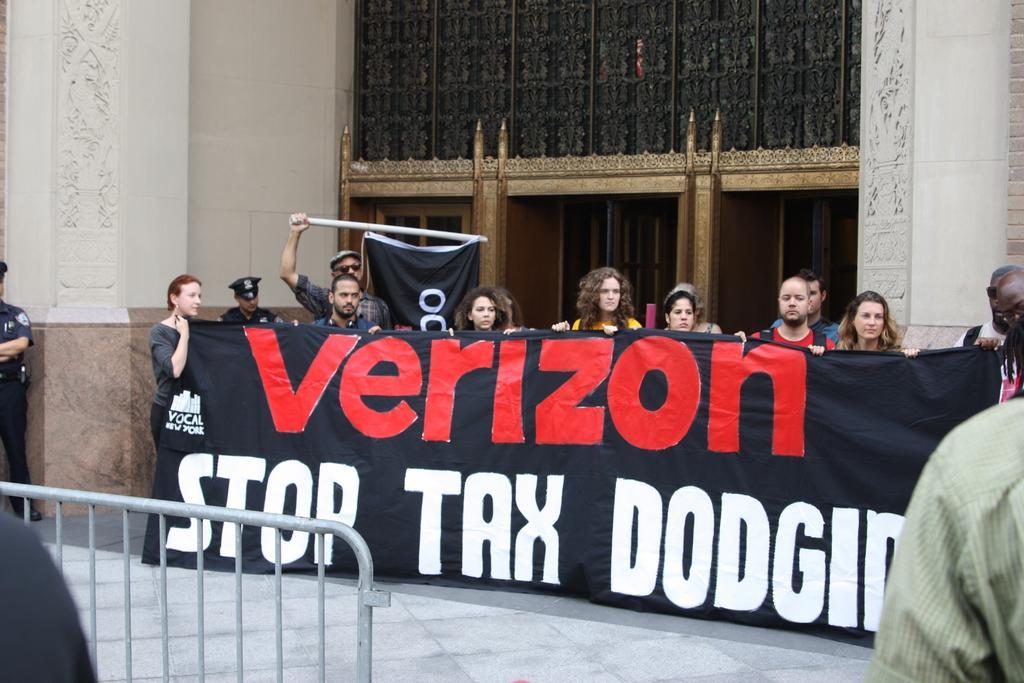In one or two sentences, can you explain what this image depicts? In the picture we some people are standing near the building and holding a banner and on it we can see a Verizon stop tax and behind them, we can see a door and in front of them we can see a path and railing and one person standing near it. 